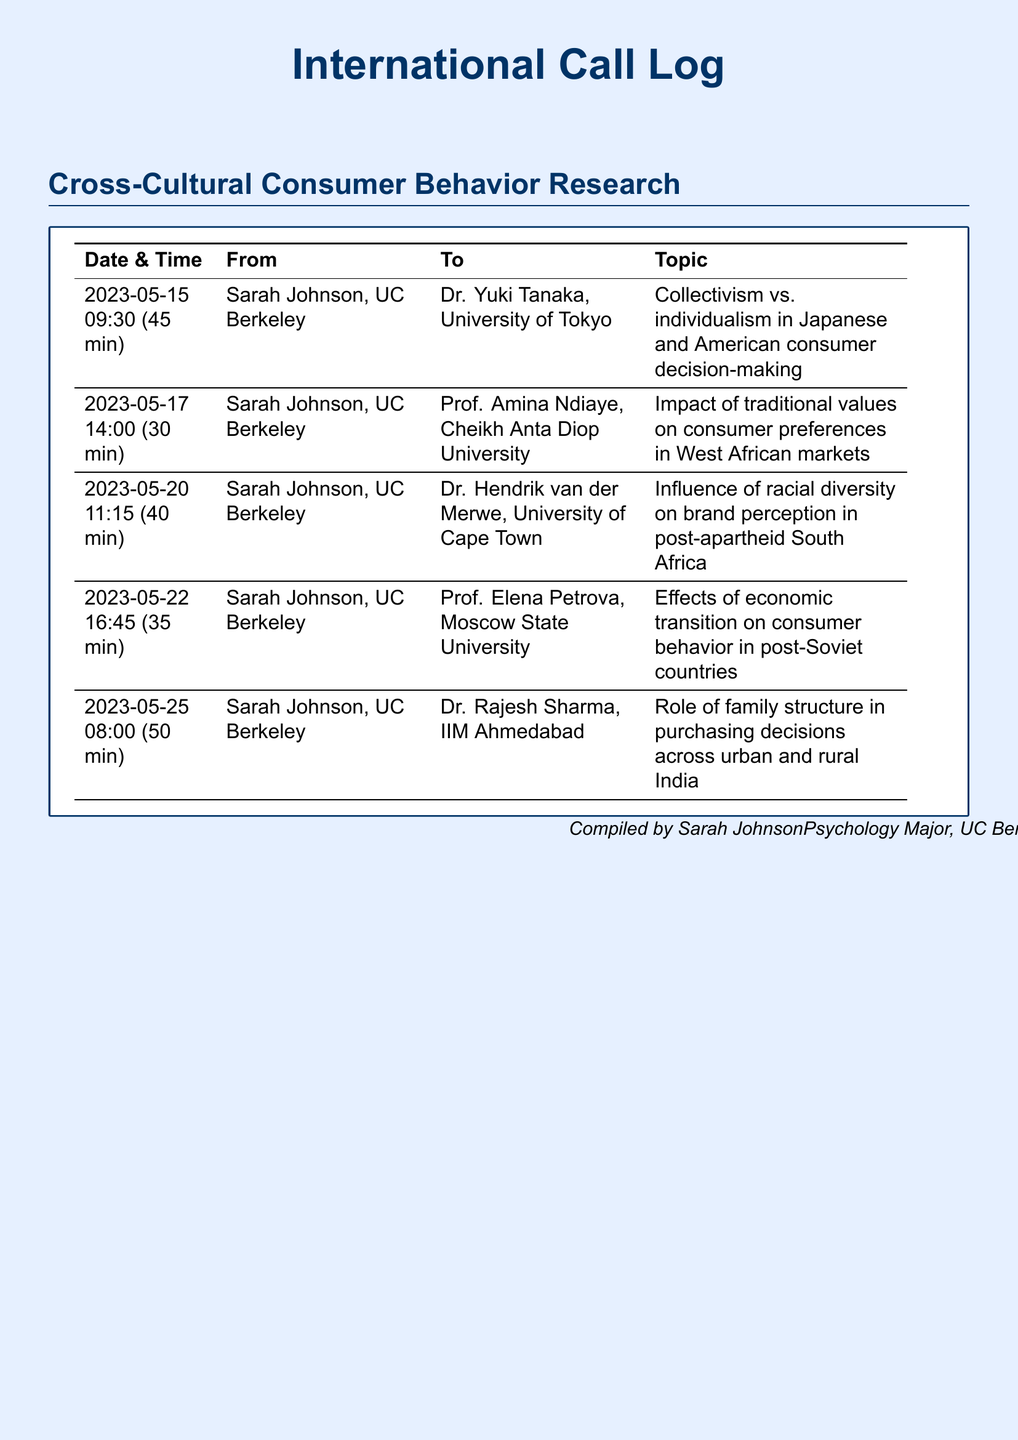What is the date of the call with Dr. Yuki Tanaka? The call with Dr. Yuki Tanaka took place on May 15, 2023.
Answer: May 15, 2023 Who was the caller in all the listed calls? The caller in all the calls was Sarah Johnson, who is from UC Berkeley.
Answer: Sarah Johnson How long was the call with Prof. Amina Ndiaye? The duration of the call with Prof. Amina Ndiaye was mentioned as 30 minutes.
Answer: 30 min What topic was discussed with Dr. Rajesh Sharma? The topic discussed with Dr. Rajesh Sharma was the role of family structure in purchasing decisions across urban and rural India.
Answer: Role of family structure in purchasing decisions across urban and rural India Which university does Dr. Hendrik van der Merwe represent? Dr. Hendrik van der Merwe is from the University of Cape Town.
Answer: University of Cape Town What is the total number of calls logged? The total number of calls logged in the document is five.
Answer: 5 Which country does Prof. Elena Petrova represent? Prof. Elena Petrova is from Moscow, which is in Russia.
Answer: Russia What was the main focus of the call with Dr. Yuki Tanaka? The main focus of the call with Dr. Yuki Tanaka was collectivism vs. individualism in consumer decision-making.
Answer: Collectivism vs. individualism in consumer decision-making 